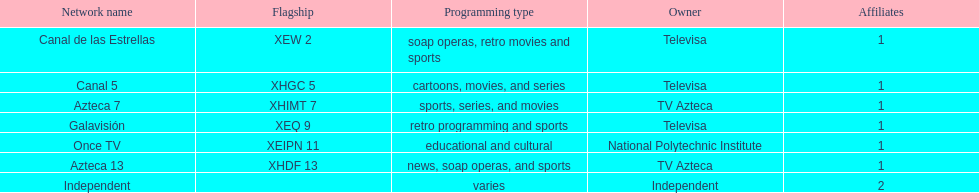I'm looking to parse the entire table for insights. Could you assist me with that? {'header': ['Network name', 'Flagship', 'Programming type', 'Owner', 'Affiliates'], 'rows': [['Canal de las Estrellas', 'XEW 2', 'soap operas, retro movies and sports', 'Televisa', '1'], ['Canal 5', 'XHGC 5', 'cartoons, movies, and series', 'Televisa', '1'], ['Azteca 7', 'XHIMT 7', 'sports, series, and movies', 'TV Azteca', '1'], ['Galavisión', 'XEQ 9', 'retro programming and sports', 'Televisa', '1'], ['Once TV', 'XEIPN 11', 'educational and cultural', 'National Polytechnic Institute', '1'], ['Azteca 13', 'XHDF 13', 'news, soap operas, and sports', 'TV Azteca', '1'], ['Independent', '', 'varies', 'Independent', '2']]} How many networks do not telecast sports? 2. 